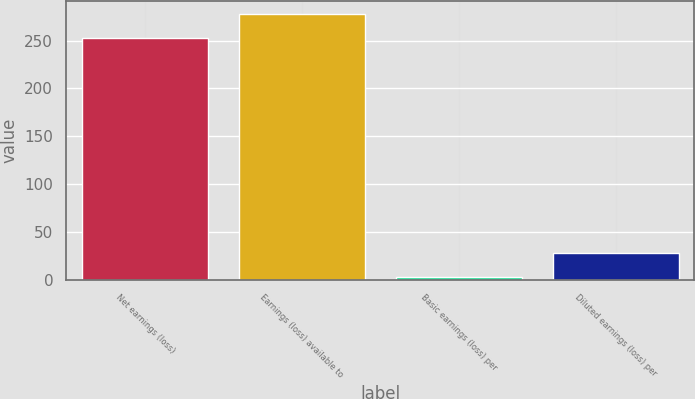Convert chart. <chart><loc_0><loc_0><loc_500><loc_500><bar_chart><fcel>Net earnings (loss)<fcel>Earnings (loss) available to<fcel>Basic earnings (loss) per<fcel>Diluted earnings (loss) per<nl><fcel>253<fcel>278.05<fcel>2.55<fcel>27.6<nl></chart> 